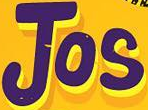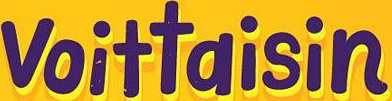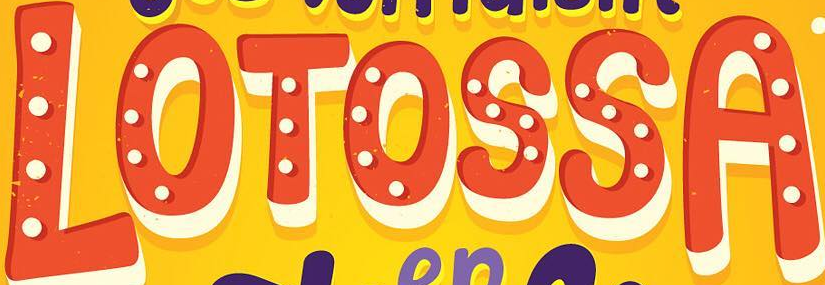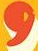What text appears in these images from left to right, separated by a semicolon? Jos; voittaisin; LOTOSSA; , 